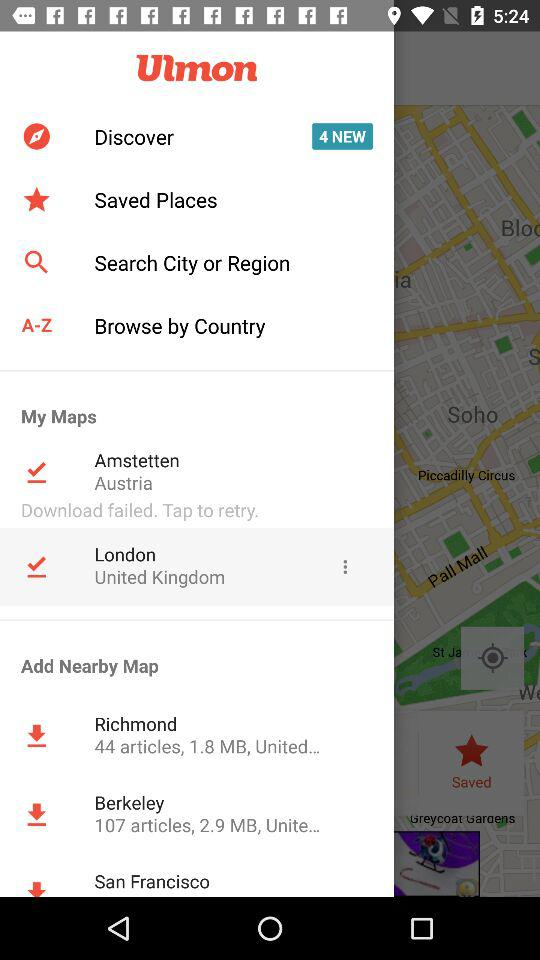What is the file size of the Richmond map in MB? The file size in MB is 1.8. 